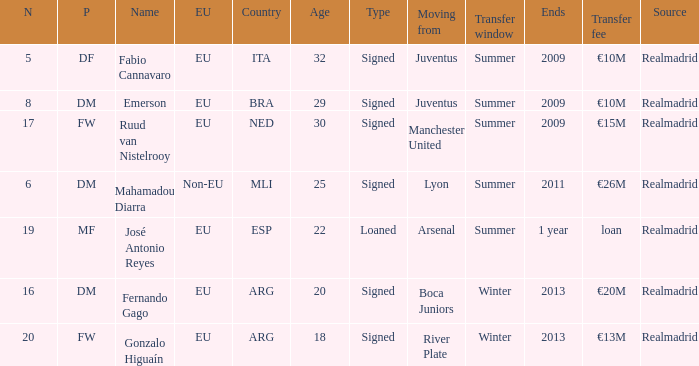How many numerals are finishing in 1 year? 1.0. 